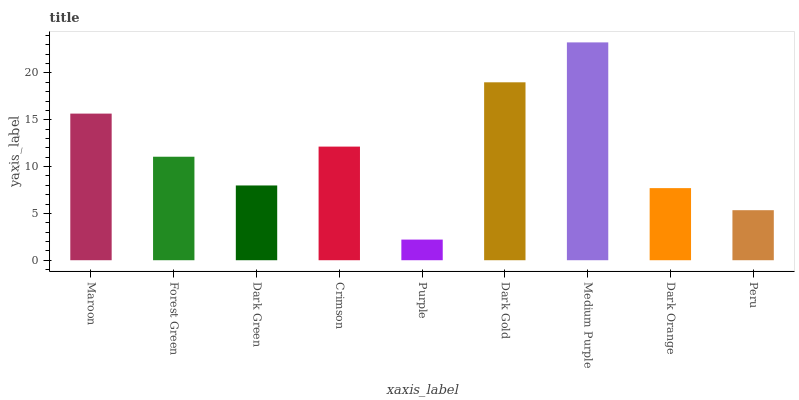Is Purple the minimum?
Answer yes or no. Yes. Is Medium Purple the maximum?
Answer yes or no. Yes. Is Forest Green the minimum?
Answer yes or no. No. Is Forest Green the maximum?
Answer yes or no. No. Is Maroon greater than Forest Green?
Answer yes or no. Yes. Is Forest Green less than Maroon?
Answer yes or no. Yes. Is Forest Green greater than Maroon?
Answer yes or no. No. Is Maroon less than Forest Green?
Answer yes or no. No. Is Forest Green the high median?
Answer yes or no. Yes. Is Forest Green the low median?
Answer yes or no. Yes. Is Medium Purple the high median?
Answer yes or no. No. Is Crimson the low median?
Answer yes or no. No. 